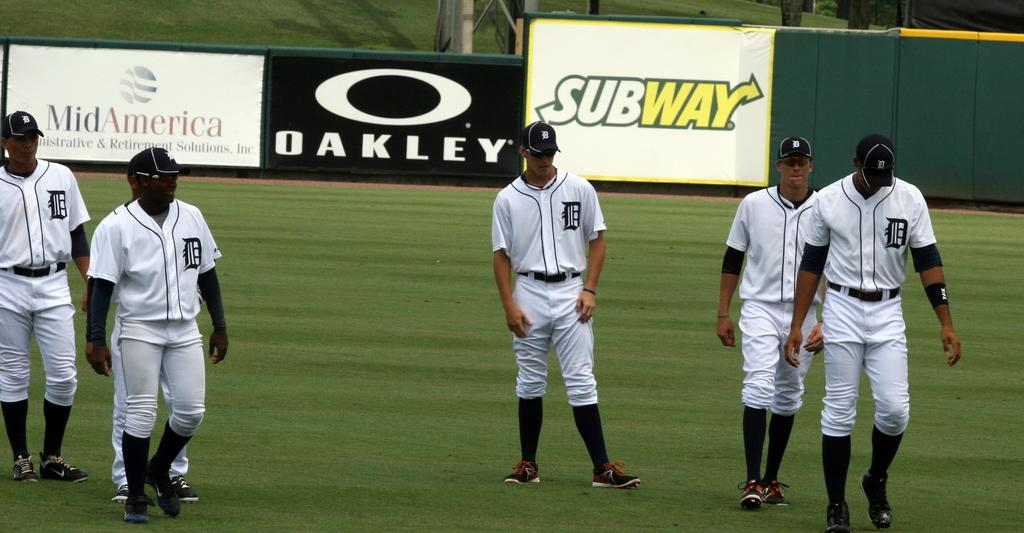<image>
Write a terse but informative summary of the picture. a baseball team walking on a field in front of ads for SUBWAY and Oakley 